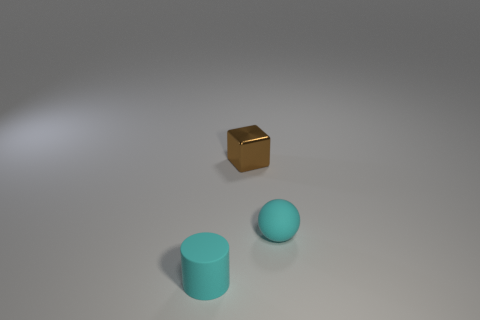Add 1 purple matte things. How many objects exist? 4 Subtract all blocks. How many objects are left? 2 Subtract 0 yellow cylinders. How many objects are left? 3 Subtract all small brown metallic things. Subtract all matte cylinders. How many objects are left? 1 Add 3 small brown shiny things. How many small brown shiny things are left? 4 Add 2 tiny cyan shiny things. How many tiny cyan shiny things exist? 2 